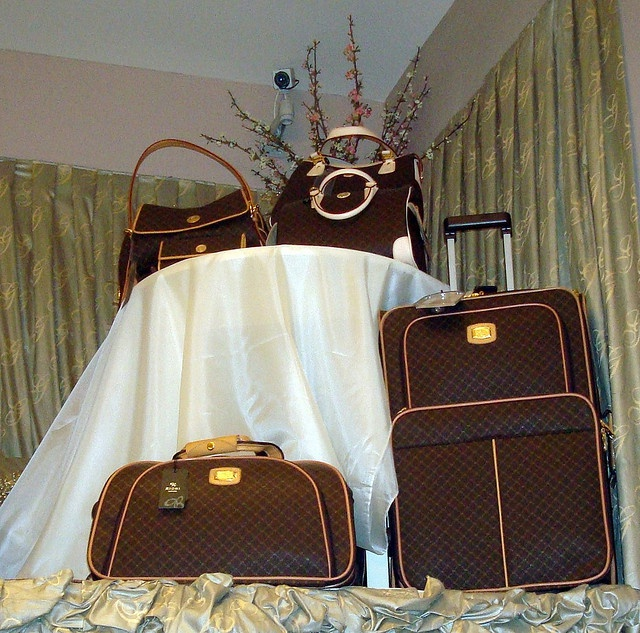Describe the objects in this image and their specific colors. I can see suitcase in gray, black, and maroon tones, handbag in gray, maroon, black, and tan tones, handbag in gray, black, maroon, and ivory tones, and handbag in gray, black, olive, and maroon tones in this image. 